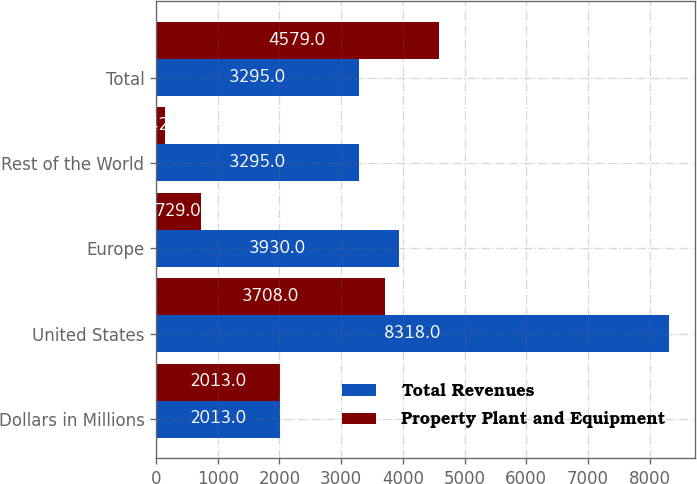Convert chart. <chart><loc_0><loc_0><loc_500><loc_500><stacked_bar_chart><ecel><fcel>Dollars in Millions<fcel>United States<fcel>Europe<fcel>Rest of the World<fcel>Total<nl><fcel>Total Revenues<fcel>2013<fcel>8318<fcel>3930<fcel>3295<fcel>3295<nl><fcel>Property Plant and Equipment<fcel>2013<fcel>3708<fcel>729<fcel>142<fcel>4579<nl></chart> 